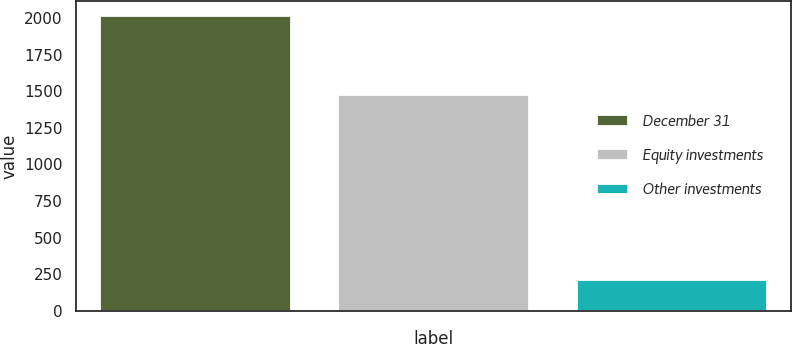Convert chart to OTSL. <chart><loc_0><loc_0><loc_500><loc_500><bar_chart><fcel>December 31<fcel>Equity investments<fcel>Other investments<nl><fcel>2015<fcel>1476<fcel>209<nl></chart> 